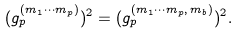<formula> <loc_0><loc_0><loc_500><loc_500>( g ^ { ( m _ { 1 } \cdots m _ { p } ) } _ { p } ) ^ { 2 } = ( g ^ { ( m _ { 1 } \cdots m _ { p } , \, m _ { b } ) } _ { p } ) ^ { 2 } .</formula> 